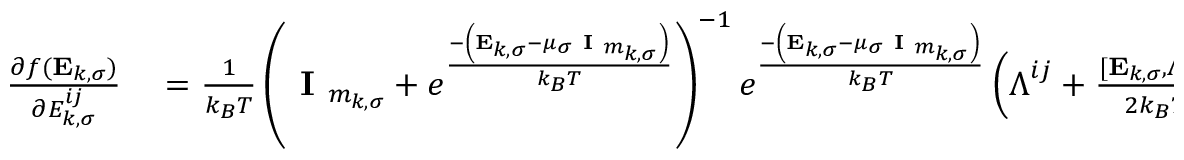<formula> <loc_0><loc_0><loc_500><loc_500>\begin{array} { r l } { \frac { \partial f ( E _ { k , \sigma } ) } { \partial { E } _ { k , \sigma } ^ { i j } } } & = \frac { 1 } { k _ { B } T } \left ( I _ { m _ { k , \sigma } } + e ^ { \frac { - \left ( E _ { k , \sigma } - \mu _ { \sigma } I _ { m _ { k , \sigma } } \right ) } { k _ { B } T } } \right ) ^ { - 1 } e ^ { \frac { - \left ( E _ { k , \sigma } - \mu _ { \sigma } I _ { m _ { k , \sigma } } \right ) } { k _ { B } T } } \left ( \Lambda ^ { i j } + \frac { [ E _ { k , \sigma } , \Lambda ^ { i j } ] } { 2 k _ { B } T } \right ) } \end{array}</formula> 